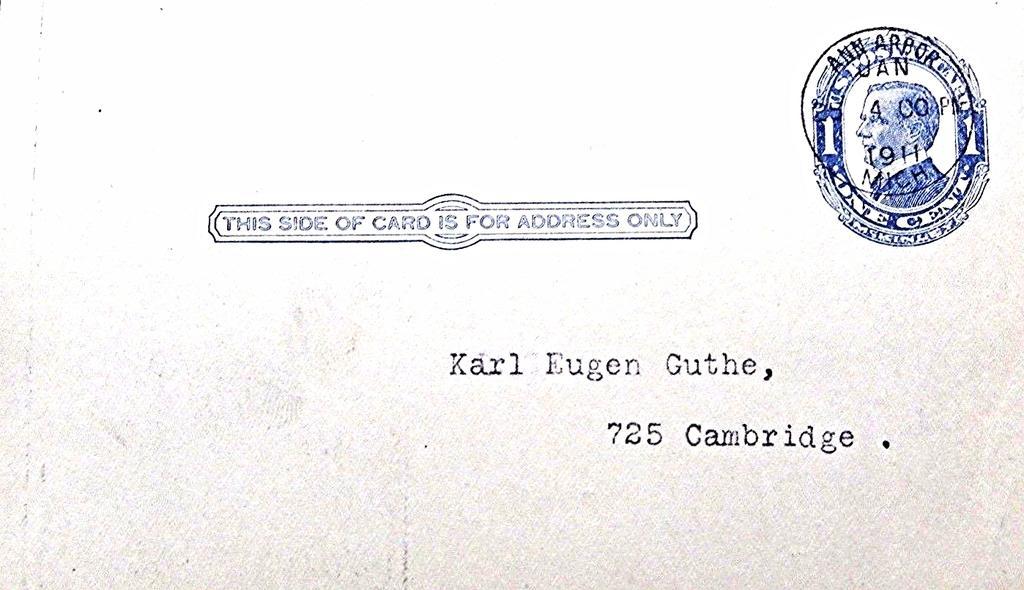Can you describe this image briefly? In this picture I can see there is a postcard, there is something written on it and there is a stamp onto the right side top corner. 